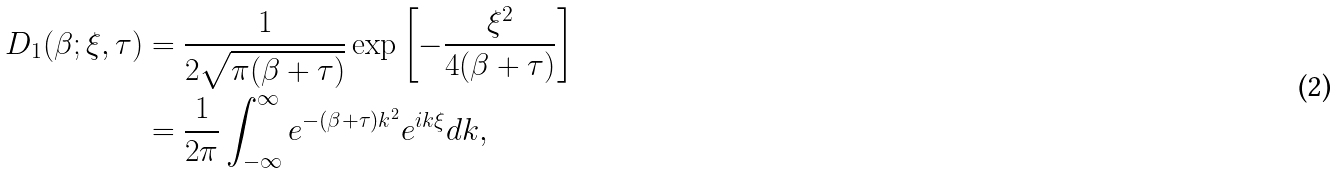Convert formula to latex. <formula><loc_0><loc_0><loc_500><loc_500>D _ { 1 } ( \beta ; \xi , \tau ) & = \frac { 1 } { 2 \sqrt { \pi ( \beta + \tau ) } } \exp \left [ - \frac { \xi ^ { 2 } } { 4 ( \beta + \tau ) } \right ] \\ & = \frac { 1 } { 2 \pi } \int _ { - \infty } ^ { \infty } e ^ { - ( \beta + \tau ) k ^ { 2 } } e ^ { i k \xi } d k ,</formula> 